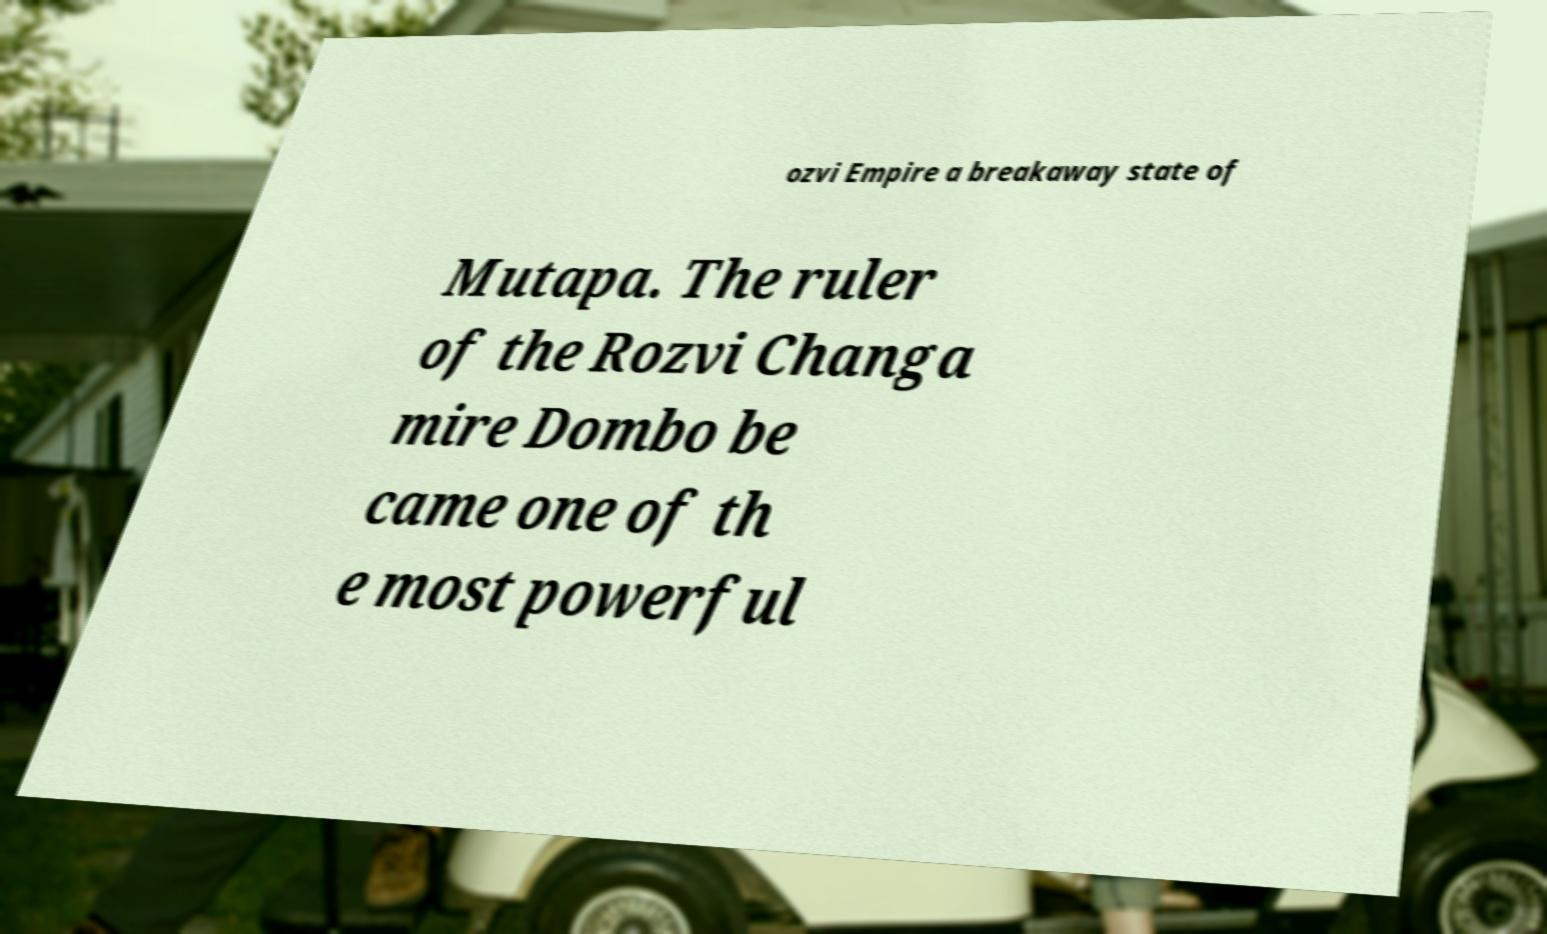I need the written content from this picture converted into text. Can you do that? ozvi Empire a breakaway state of Mutapa. The ruler of the Rozvi Changa mire Dombo be came one of th e most powerful 